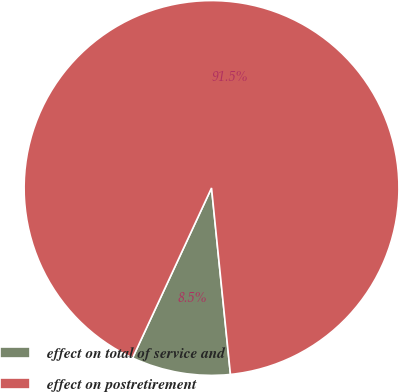Convert chart. <chart><loc_0><loc_0><loc_500><loc_500><pie_chart><fcel>effect on total of service and<fcel>effect on postretirement<nl><fcel>8.53%<fcel>91.47%<nl></chart> 